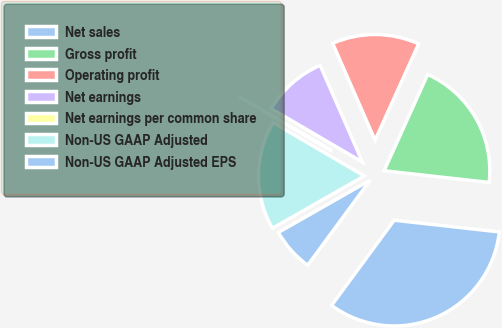Convert chart. <chart><loc_0><loc_0><loc_500><loc_500><pie_chart><fcel>Net sales<fcel>Gross profit<fcel>Operating profit<fcel>Net earnings<fcel>Net earnings per common share<fcel>Non-US GAAP Adjusted<fcel>Non-US GAAP Adjusted EPS<nl><fcel>33.32%<fcel>20.0%<fcel>13.33%<fcel>10.0%<fcel>0.01%<fcel>16.66%<fcel>6.67%<nl></chart> 